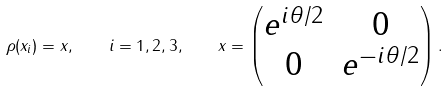Convert formula to latex. <formula><loc_0><loc_0><loc_500><loc_500>\rho ( x _ { i } ) = x , \quad i = 1 , 2 , 3 , \quad x = \begin{pmatrix} e ^ { i \theta / 2 } & 0 \\ 0 & e ^ { - i \theta / 2 } \end{pmatrix} .</formula> 